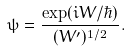<formula> <loc_0><loc_0><loc_500><loc_500>\psi = \frac { \exp ( i W / \hbar { ) } } { ( W ^ { \prime } ) ^ { 1 / 2 } } .</formula> 